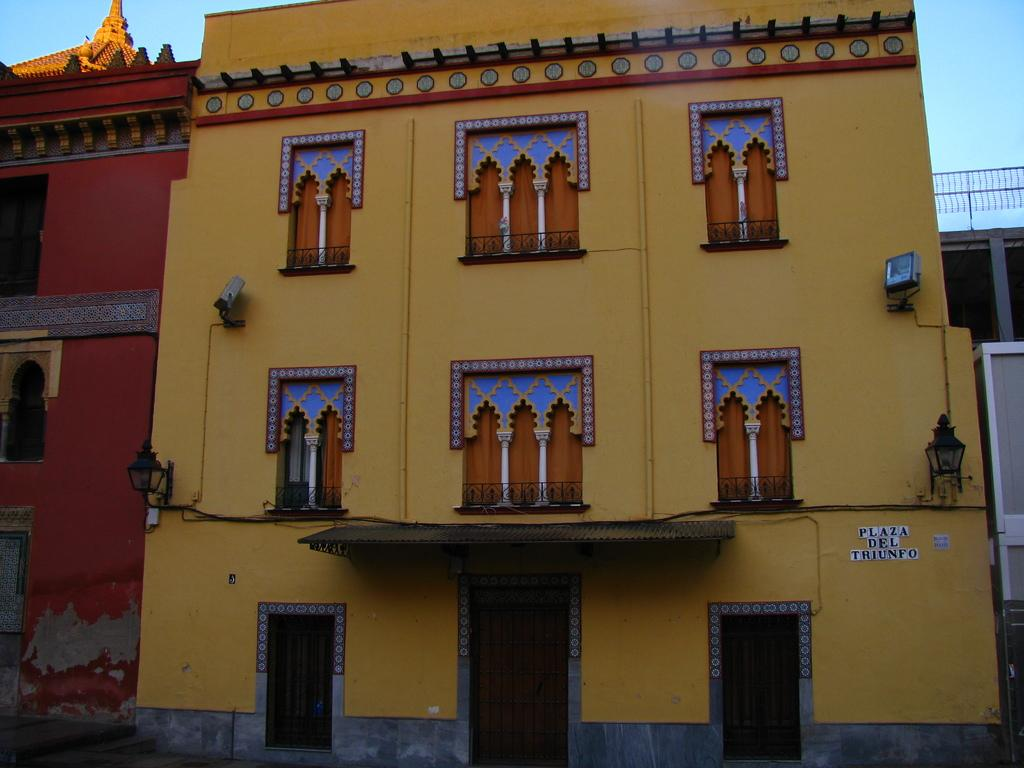What type of structures are present in the image? There are buildings in the image. What features can be observed on the buildings? The buildings have windows and lights. What colors are the buildings? The buildings are in yellow, red, and blue colors. What can be seen in the background of the image? The sky is visible in the background of the image. What type of print can be seen on the dad's shirt in the image? There is no dad or shirt present in the image; it features buildings with windows, lights, and specific colors. 